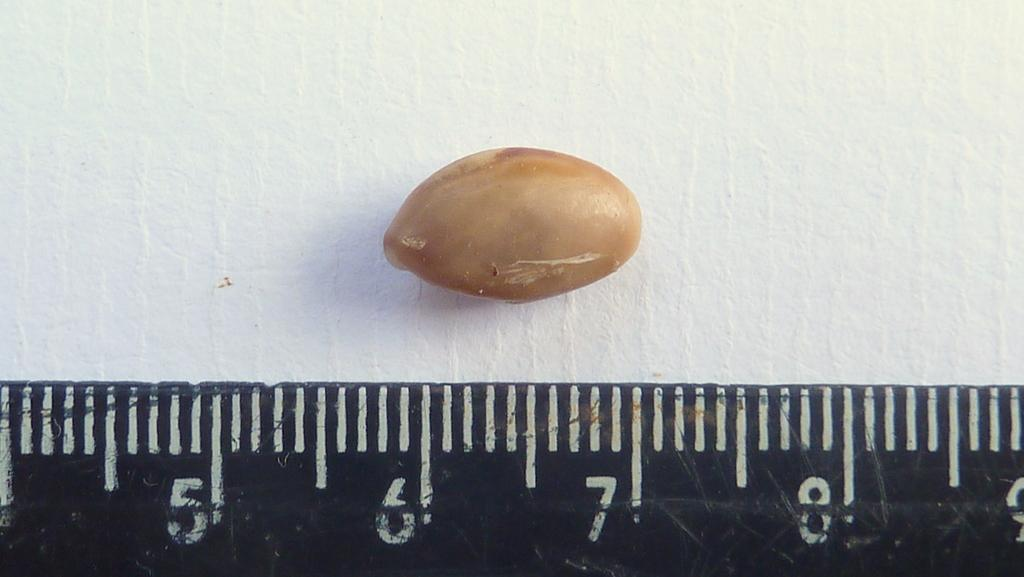<image>
Provide a brief description of the given image. A peanut sits above the ruler measuring from 6 to 7. 